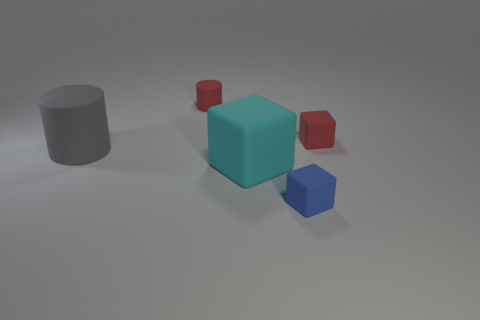What is the color of the cylinder that is in front of the tiny red block?
Your answer should be very brief. Gray. What is the size of the red matte cube?
Give a very brief answer. Small. There is a blue block; is its size the same as the matte cylinder that is in front of the red block?
Provide a succinct answer. No. What is the color of the tiny block behind the tiny matte object that is in front of the rubber cylinder that is in front of the red matte cylinder?
Provide a short and direct response. Red. How many other objects are the same material as the blue thing?
Make the answer very short. 4. There is a big object that is in front of the gray rubber object; is it the same shape as the small matte thing that is left of the blue thing?
Provide a succinct answer. No. What shape is the gray matte thing that is the same size as the cyan cube?
Make the answer very short. Cylinder. Is the tiny red thing to the right of the big cyan rubber block made of the same material as the big object that is in front of the big gray rubber object?
Give a very brief answer. Yes. Is there a small red matte thing that is behind the red object that is to the left of the cyan matte object?
Ensure brevity in your answer.  No. The small cylinder that is the same material as the big cyan cube is what color?
Keep it short and to the point. Red. 